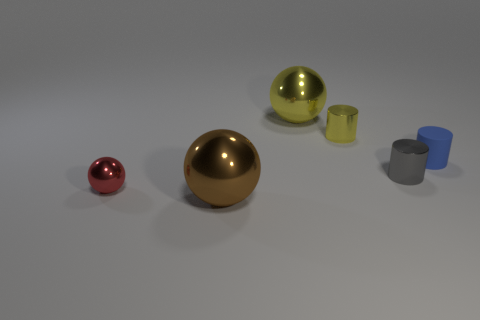Add 4 yellow things. How many objects exist? 10 Add 5 large cyan cubes. How many large cyan cubes exist? 5 Subtract 0 cyan cylinders. How many objects are left? 6 Subtract all big purple balls. Subtract all big brown objects. How many objects are left? 5 Add 6 brown objects. How many brown objects are left? 7 